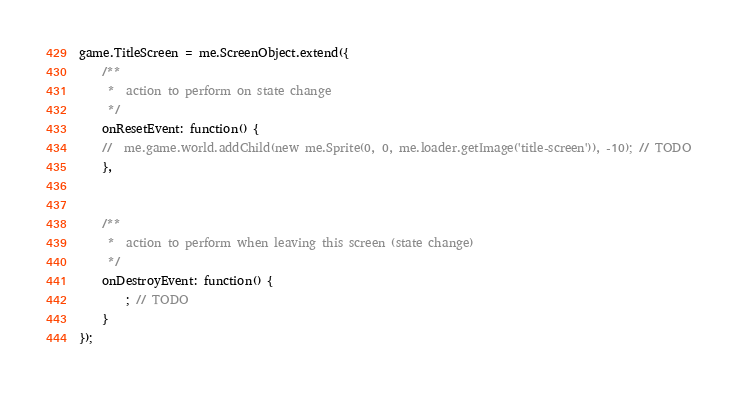<code> <loc_0><loc_0><loc_500><loc_500><_JavaScript_>game.TitleScreen = me.ScreenObject.extend({
	/**	
	 *  action to perform on state change
	 */
	onResetEvent: function() {	
	//	me.game.world.addChild(new me.Sprite(0, 0, me.loader.getImage('title-screen')), -10); // TODO
	},
	
	
	/**	
	 *  action to perform when leaving this screen (state change)
	 */
	onDestroyEvent: function() {
		; // TODO
	}
});
</code> 